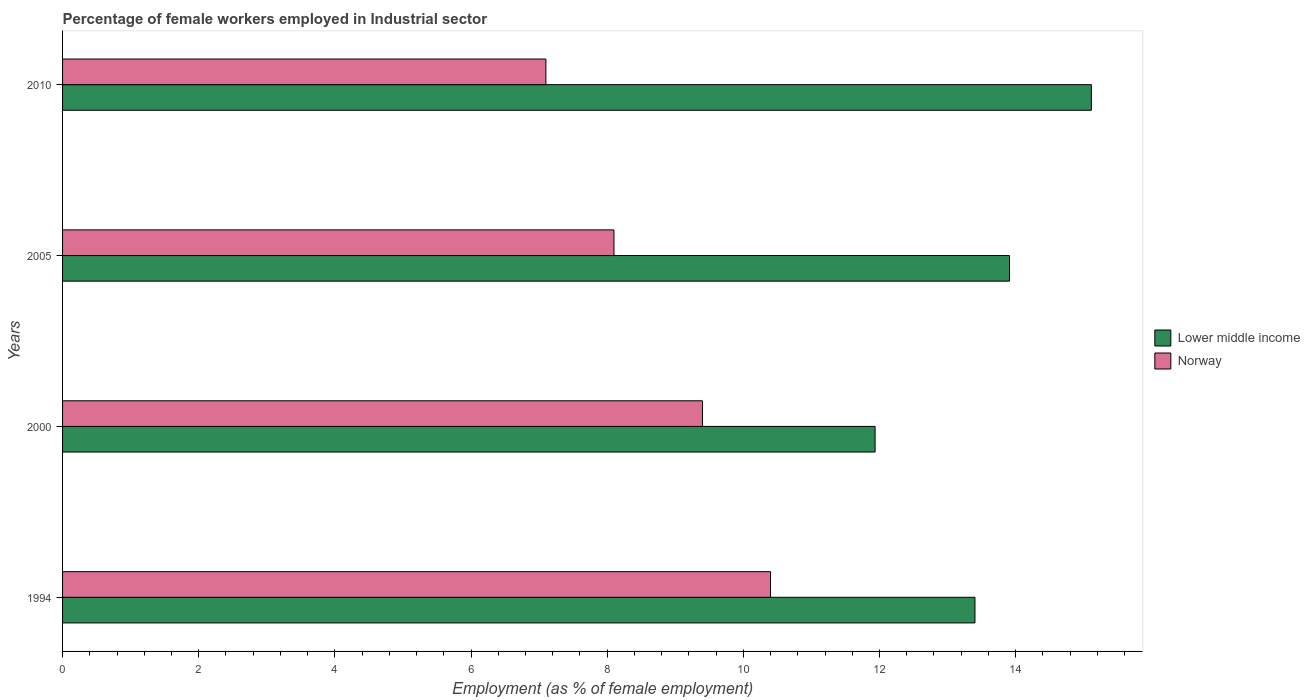How many different coloured bars are there?
Your answer should be very brief. 2. How many groups of bars are there?
Your answer should be very brief. 4. Are the number of bars on each tick of the Y-axis equal?
Ensure brevity in your answer.  Yes. How many bars are there on the 2nd tick from the bottom?
Your answer should be compact. 2. What is the label of the 2nd group of bars from the top?
Offer a terse response. 2005. What is the percentage of females employed in Industrial sector in Lower middle income in 2010?
Your response must be concise. 15.11. Across all years, what is the maximum percentage of females employed in Industrial sector in Norway?
Your response must be concise. 10.4. Across all years, what is the minimum percentage of females employed in Industrial sector in Norway?
Make the answer very short. 7.1. In which year was the percentage of females employed in Industrial sector in Lower middle income maximum?
Offer a very short reply. 2010. In which year was the percentage of females employed in Industrial sector in Lower middle income minimum?
Give a very brief answer. 2000. What is the total percentage of females employed in Industrial sector in Norway in the graph?
Your response must be concise. 35. What is the difference between the percentage of females employed in Industrial sector in Norway in 1994 and that in 2010?
Offer a very short reply. 3.3. What is the difference between the percentage of females employed in Industrial sector in Lower middle income in 2005 and the percentage of females employed in Industrial sector in Norway in 2000?
Give a very brief answer. 4.51. What is the average percentage of females employed in Industrial sector in Norway per year?
Offer a terse response. 8.75. In the year 2010, what is the difference between the percentage of females employed in Industrial sector in Lower middle income and percentage of females employed in Industrial sector in Norway?
Your response must be concise. 8.01. In how many years, is the percentage of females employed in Industrial sector in Lower middle income greater than 4 %?
Give a very brief answer. 4. What is the ratio of the percentage of females employed in Industrial sector in Norway in 1994 to that in 2010?
Give a very brief answer. 1.46. Is the percentage of females employed in Industrial sector in Norway in 2000 less than that in 2005?
Your answer should be very brief. No. What is the difference between the highest and the second highest percentage of females employed in Industrial sector in Lower middle income?
Make the answer very short. 1.2. What is the difference between the highest and the lowest percentage of females employed in Industrial sector in Norway?
Make the answer very short. 3.3. In how many years, is the percentage of females employed in Industrial sector in Norway greater than the average percentage of females employed in Industrial sector in Norway taken over all years?
Your answer should be very brief. 2. What does the 2nd bar from the top in 2010 represents?
Provide a succinct answer. Lower middle income. What does the 1st bar from the bottom in 1994 represents?
Ensure brevity in your answer.  Lower middle income. How many bars are there?
Make the answer very short. 8. Are all the bars in the graph horizontal?
Ensure brevity in your answer.  Yes. Are the values on the major ticks of X-axis written in scientific E-notation?
Give a very brief answer. No. Does the graph contain grids?
Your answer should be compact. No. How are the legend labels stacked?
Provide a short and direct response. Vertical. What is the title of the graph?
Make the answer very short. Percentage of female workers employed in Industrial sector. What is the label or title of the X-axis?
Keep it short and to the point. Employment (as % of female employment). What is the label or title of the Y-axis?
Keep it short and to the point. Years. What is the Employment (as % of female employment) in Lower middle income in 1994?
Give a very brief answer. 13.4. What is the Employment (as % of female employment) of Norway in 1994?
Your response must be concise. 10.4. What is the Employment (as % of female employment) in Lower middle income in 2000?
Offer a very short reply. 11.94. What is the Employment (as % of female employment) of Norway in 2000?
Your answer should be very brief. 9.4. What is the Employment (as % of female employment) in Lower middle income in 2005?
Provide a short and direct response. 13.91. What is the Employment (as % of female employment) of Norway in 2005?
Give a very brief answer. 8.1. What is the Employment (as % of female employment) of Lower middle income in 2010?
Provide a short and direct response. 15.11. What is the Employment (as % of female employment) in Norway in 2010?
Ensure brevity in your answer.  7.1. Across all years, what is the maximum Employment (as % of female employment) of Lower middle income?
Your answer should be compact. 15.11. Across all years, what is the maximum Employment (as % of female employment) of Norway?
Ensure brevity in your answer.  10.4. Across all years, what is the minimum Employment (as % of female employment) in Lower middle income?
Your response must be concise. 11.94. Across all years, what is the minimum Employment (as % of female employment) in Norway?
Provide a short and direct response. 7.1. What is the total Employment (as % of female employment) in Lower middle income in the graph?
Your response must be concise. 54.36. What is the difference between the Employment (as % of female employment) in Lower middle income in 1994 and that in 2000?
Provide a short and direct response. 1.47. What is the difference between the Employment (as % of female employment) of Norway in 1994 and that in 2000?
Give a very brief answer. 1. What is the difference between the Employment (as % of female employment) of Lower middle income in 1994 and that in 2005?
Ensure brevity in your answer.  -0.51. What is the difference between the Employment (as % of female employment) of Norway in 1994 and that in 2005?
Give a very brief answer. 2.3. What is the difference between the Employment (as % of female employment) of Lower middle income in 1994 and that in 2010?
Provide a short and direct response. -1.71. What is the difference between the Employment (as % of female employment) of Norway in 1994 and that in 2010?
Your response must be concise. 3.3. What is the difference between the Employment (as % of female employment) of Lower middle income in 2000 and that in 2005?
Ensure brevity in your answer.  -1.97. What is the difference between the Employment (as % of female employment) of Lower middle income in 2000 and that in 2010?
Offer a very short reply. -3.18. What is the difference between the Employment (as % of female employment) of Norway in 2000 and that in 2010?
Offer a very short reply. 2.3. What is the difference between the Employment (as % of female employment) in Lower middle income in 2005 and that in 2010?
Offer a very short reply. -1.2. What is the difference between the Employment (as % of female employment) in Lower middle income in 1994 and the Employment (as % of female employment) in Norway in 2000?
Ensure brevity in your answer.  4. What is the difference between the Employment (as % of female employment) in Lower middle income in 1994 and the Employment (as % of female employment) in Norway in 2005?
Provide a succinct answer. 5.3. What is the difference between the Employment (as % of female employment) in Lower middle income in 1994 and the Employment (as % of female employment) in Norway in 2010?
Offer a very short reply. 6.3. What is the difference between the Employment (as % of female employment) of Lower middle income in 2000 and the Employment (as % of female employment) of Norway in 2005?
Provide a succinct answer. 3.84. What is the difference between the Employment (as % of female employment) in Lower middle income in 2000 and the Employment (as % of female employment) in Norway in 2010?
Your answer should be very brief. 4.84. What is the difference between the Employment (as % of female employment) of Lower middle income in 2005 and the Employment (as % of female employment) of Norway in 2010?
Offer a very short reply. 6.81. What is the average Employment (as % of female employment) of Lower middle income per year?
Provide a succinct answer. 13.59. What is the average Employment (as % of female employment) of Norway per year?
Offer a terse response. 8.75. In the year 1994, what is the difference between the Employment (as % of female employment) in Lower middle income and Employment (as % of female employment) in Norway?
Provide a succinct answer. 3. In the year 2000, what is the difference between the Employment (as % of female employment) of Lower middle income and Employment (as % of female employment) of Norway?
Provide a succinct answer. 2.54. In the year 2005, what is the difference between the Employment (as % of female employment) in Lower middle income and Employment (as % of female employment) in Norway?
Your answer should be compact. 5.81. In the year 2010, what is the difference between the Employment (as % of female employment) of Lower middle income and Employment (as % of female employment) of Norway?
Your response must be concise. 8.01. What is the ratio of the Employment (as % of female employment) in Lower middle income in 1994 to that in 2000?
Ensure brevity in your answer.  1.12. What is the ratio of the Employment (as % of female employment) in Norway in 1994 to that in 2000?
Keep it short and to the point. 1.11. What is the ratio of the Employment (as % of female employment) in Lower middle income in 1994 to that in 2005?
Make the answer very short. 0.96. What is the ratio of the Employment (as % of female employment) of Norway in 1994 to that in 2005?
Ensure brevity in your answer.  1.28. What is the ratio of the Employment (as % of female employment) of Lower middle income in 1994 to that in 2010?
Your response must be concise. 0.89. What is the ratio of the Employment (as % of female employment) in Norway in 1994 to that in 2010?
Make the answer very short. 1.46. What is the ratio of the Employment (as % of female employment) in Lower middle income in 2000 to that in 2005?
Offer a very short reply. 0.86. What is the ratio of the Employment (as % of female employment) of Norway in 2000 to that in 2005?
Your response must be concise. 1.16. What is the ratio of the Employment (as % of female employment) in Lower middle income in 2000 to that in 2010?
Provide a succinct answer. 0.79. What is the ratio of the Employment (as % of female employment) of Norway in 2000 to that in 2010?
Offer a terse response. 1.32. What is the ratio of the Employment (as % of female employment) in Lower middle income in 2005 to that in 2010?
Provide a short and direct response. 0.92. What is the ratio of the Employment (as % of female employment) of Norway in 2005 to that in 2010?
Ensure brevity in your answer.  1.14. What is the difference between the highest and the second highest Employment (as % of female employment) of Lower middle income?
Make the answer very short. 1.2. What is the difference between the highest and the second highest Employment (as % of female employment) of Norway?
Provide a succinct answer. 1. What is the difference between the highest and the lowest Employment (as % of female employment) in Lower middle income?
Your answer should be compact. 3.18. 